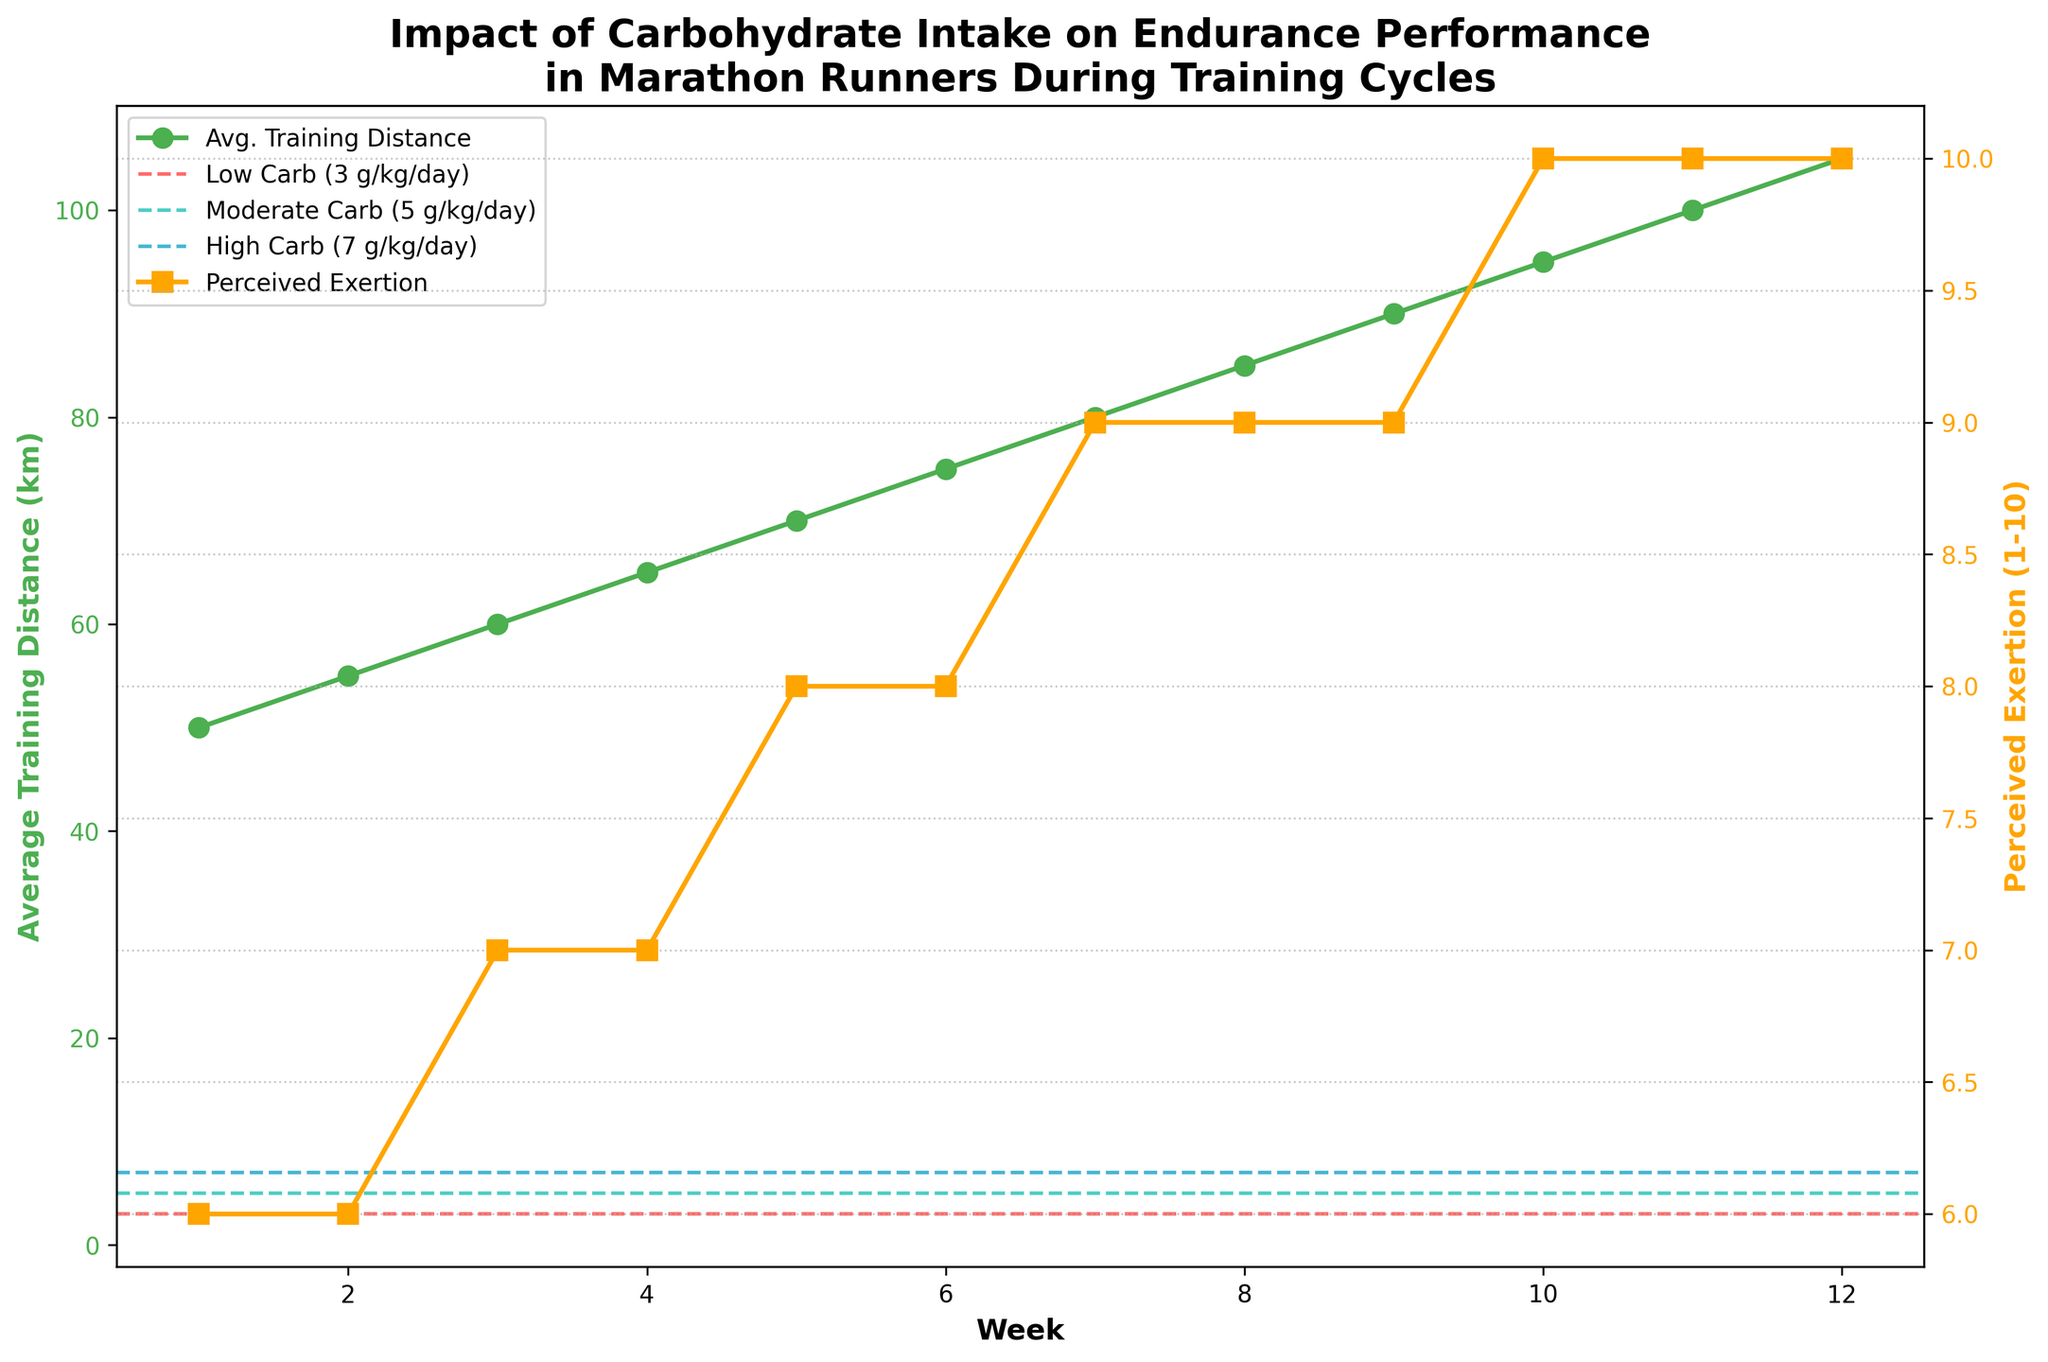What is the average perceived exertion over the 12 weeks? Sum the perceived exertions over the 12 weeks: (6 + 6 + 7 + 7 + 8 + 8 + 9 + 9 + 9 + 10 + 10 + 10) = 99. There are 12 weeks, so the average perceived exertion is 99/12 ≈ 8.25
Answer: 8.25 By how much does the average training distance increase from week 1 to week 12? The average training distance in week 1 is 50 km and in week 12 is 105 km. The increase is 105 - 50 = 55 km
Answer: 55 km Which week shows the biggest increase in perceived exertion compared to the previous week? Examine the increase in perceived exertion for each week compared to its previous week. The biggest increase is between weeks 4 and 5, where it changes from 7 to 8, an increase of 1 unit
Answer: Week 5 How do low, moderate, and high carbohydrate intake levels compare visually on the plot? The low carbohydrate intake is indicated by a dashed line at 3 g/kg/day, the moderate at 5 g/kg/day, and the high at 7 g/kg/day. They are all horizontal lines with different colors.
Answer: As horizontal dashed lines at different heights Which plot line shows a consistent increase throughout the training cycle? The average training distance starts at 50 km and increases steadily each week up to 105 km. Therefore, its plot line shows a consistent increase.
Answer: Average training distance What is the perceived exertion when the average training distance reaches 70 km? Locate the point where the average training distance is 70 km, which is week 5. At this week, the perceived exertion is 8.
Answer: 8 Does the perceived exertion ever reach a value higher than 9? Observing the perceived exertion values, it reaches but does not go above 10 during weeks 10, 11, and 12.
Answer: Yes Comparing week 7 to week 10, how much higher is the average training distance? The average training distance in week 7 is 80 km, and in week 10 it is 95 km. The difference is 95 - 80 = 15 km.
Answer: 15 km 